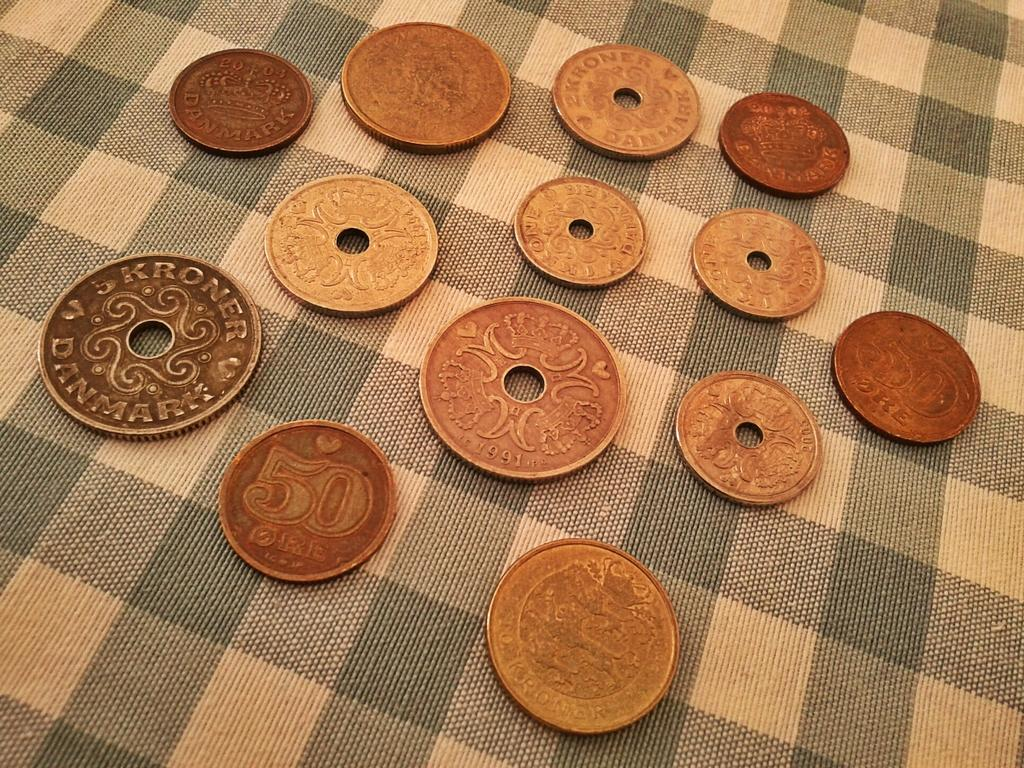What objects are present in the image? There are a few coins in the image. What is the coins placed on? The coins are on a cloth. Where are the coins and cloth located in the image? The coins and cloth are in the middle of the image. What type of base is supporting the coins and cloth in the image? There is no base visible in the image; it only shows the coins and cloth. What kind of argument is being made by the coins and cloth in the image? The coins and cloth are not making any argument in the image; they are simply objects placed on a surface. 